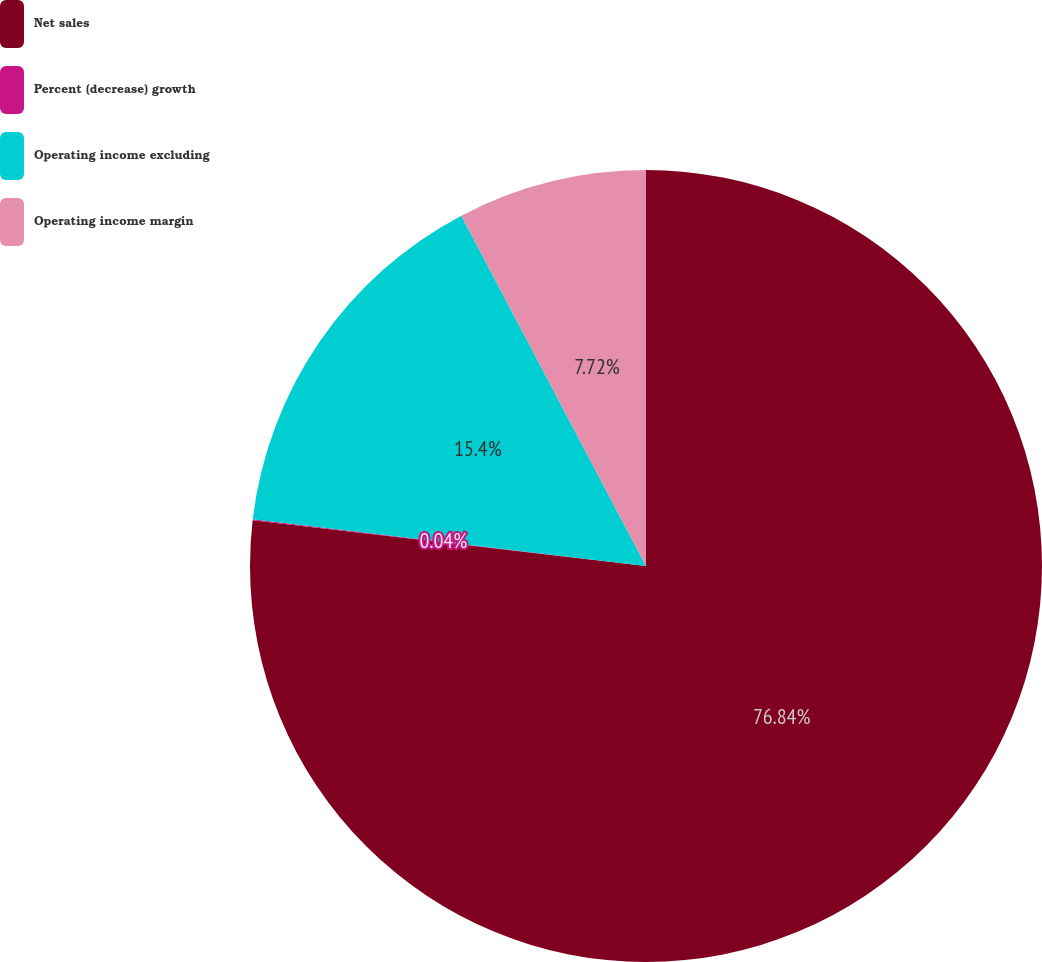Convert chart. <chart><loc_0><loc_0><loc_500><loc_500><pie_chart><fcel>Net sales<fcel>Percent (decrease) growth<fcel>Operating income excluding<fcel>Operating income margin<nl><fcel>76.84%<fcel>0.04%<fcel>15.4%<fcel>7.72%<nl></chart> 